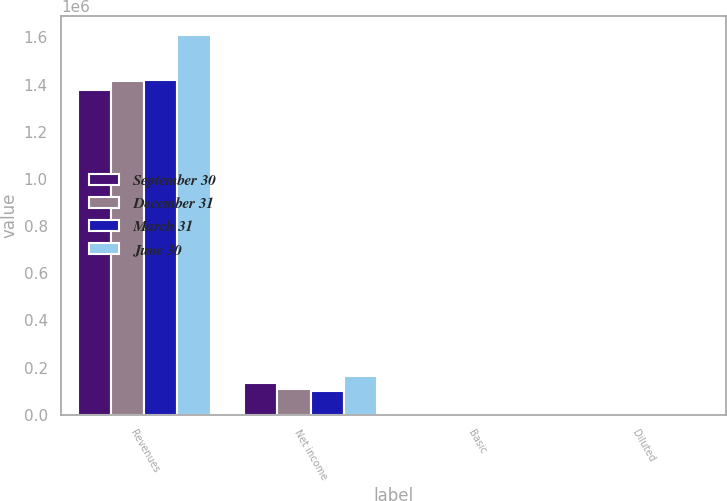Convert chart to OTSL. <chart><loc_0><loc_0><loc_500><loc_500><stacked_bar_chart><ecel><fcel>Revenues<fcel>Net income<fcel>Basic<fcel>Diluted<nl><fcel>September 30<fcel>1.3787e+06<fcel>135318<fcel>0.98<fcel>0.94<nl><fcel>December 31<fcel>1.41575e+06<fcel>108838<fcel>0.79<fcel>0.76<nl><fcel>March 31<fcel>1.4205e+06<fcel>100947<fcel>0.74<fcel>0.71<nl><fcel>June 30<fcel>1.6086e+06<fcel>165489<fcel>1.22<fcel>1.17<nl></chart> 